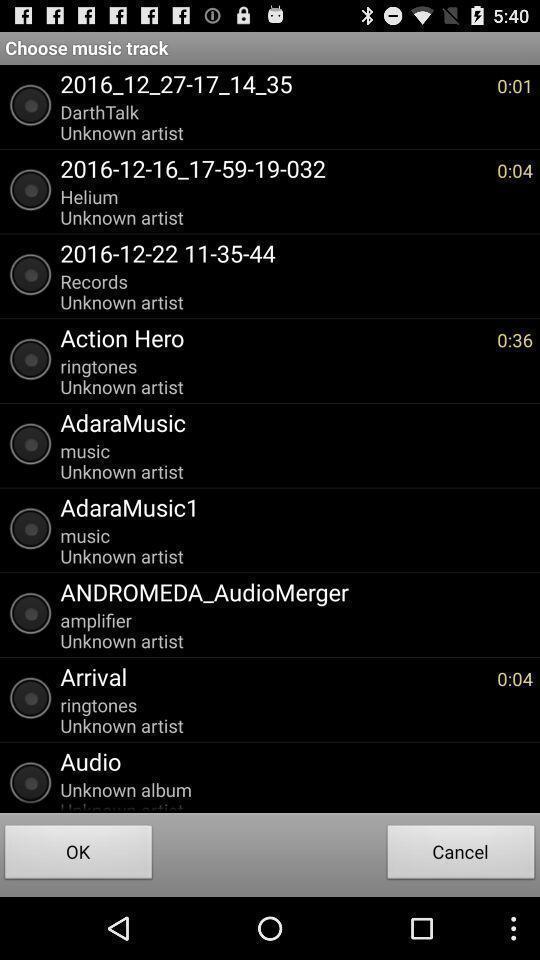What details can you identify in this image? Screen shows to choose a music track. 